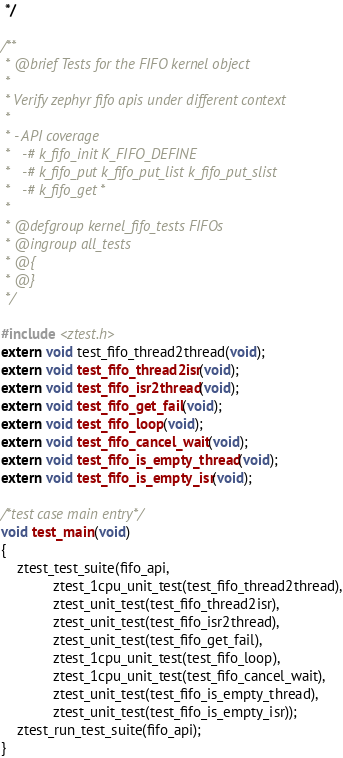<code> <loc_0><loc_0><loc_500><loc_500><_C_> */

/**
 * @brief Tests for the FIFO kernel object
 *
 * Verify zephyr fifo apis under different context
 *
 * - API coverage
 *   -# k_fifo_init K_FIFO_DEFINE
 *   -# k_fifo_put k_fifo_put_list k_fifo_put_slist
 *   -# k_fifo_get *
 *
 * @defgroup kernel_fifo_tests FIFOs
 * @ingroup all_tests
 * @{
 * @}
 */

#include <ztest.h>
extern void test_fifo_thread2thread(void);
extern void test_fifo_thread2isr(void);
extern void test_fifo_isr2thread(void);
extern void test_fifo_get_fail(void);
extern void test_fifo_loop(void);
extern void test_fifo_cancel_wait(void);
extern void test_fifo_is_empty_thread(void);
extern void test_fifo_is_empty_isr(void);

/*test case main entry*/
void test_main(void)
{
	ztest_test_suite(fifo_api,
			 ztest_1cpu_unit_test(test_fifo_thread2thread),
			 ztest_unit_test(test_fifo_thread2isr),
			 ztest_unit_test(test_fifo_isr2thread),
			 ztest_unit_test(test_fifo_get_fail),
			 ztest_1cpu_unit_test(test_fifo_loop),
			 ztest_1cpu_unit_test(test_fifo_cancel_wait),
			 ztest_unit_test(test_fifo_is_empty_thread),
			 ztest_unit_test(test_fifo_is_empty_isr));
	ztest_run_test_suite(fifo_api);
}
</code> 